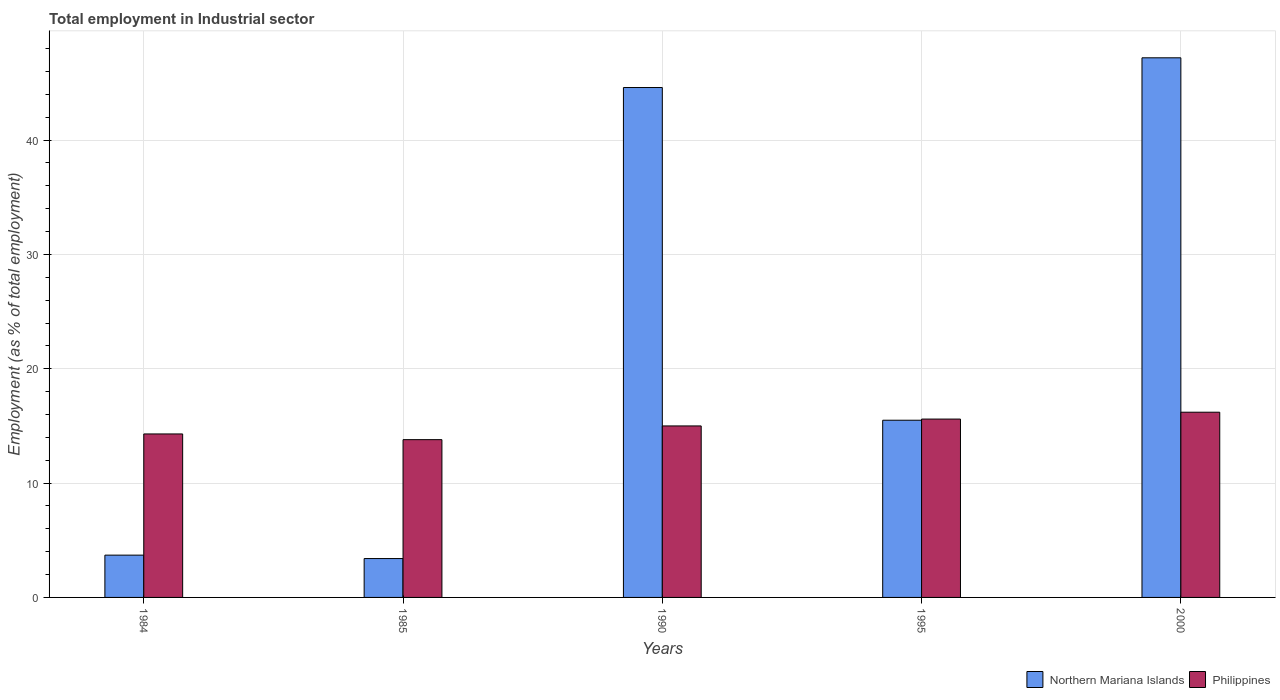How many different coloured bars are there?
Your answer should be very brief. 2. Are the number of bars per tick equal to the number of legend labels?
Your answer should be compact. Yes. What is the label of the 2nd group of bars from the left?
Your answer should be compact. 1985. In how many cases, is the number of bars for a given year not equal to the number of legend labels?
Offer a very short reply. 0. What is the employment in industrial sector in Philippines in 2000?
Make the answer very short. 16.2. Across all years, what is the maximum employment in industrial sector in Philippines?
Your answer should be compact. 16.2. Across all years, what is the minimum employment in industrial sector in Philippines?
Offer a terse response. 13.8. In which year was the employment in industrial sector in Philippines maximum?
Keep it short and to the point. 2000. In which year was the employment in industrial sector in Philippines minimum?
Your answer should be very brief. 1985. What is the total employment in industrial sector in Philippines in the graph?
Your answer should be compact. 74.9. What is the difference between the employment in industrial sector in Philippines in 1995 and that in 2000?
Keep it short and to the point. -0.6. What is the difference between the employment in industrial sector in Philippines in 1995 and the employment in industrial sector in Northern Mariana Islands in 1984?
Your answer should be very brief. 11.9. What is the average employment in industrial sector in Northern Mariana Islands per year?
Provide a succinct answer. 22.88. In the year 1985, what is the difference between the employment in industrial sector in Philippines and employment in industrial sector in Northern Mariana Islands?
Provide a succinct answer. 10.4. What is the ratio of the employment in industrial sector in Philippines in 1995 to that in 2000?
Ensure brevity in your answer.  0.96. Is the employment in industrial sector in Northern Mariana Islands in 1984 less than that in 2000?
Your response must be concise. Yes. What is the difference between the highest and the second highest employment in industrial sector in Philippines?
Ensure brevity in your answer.  0.6. What is the difference between the highest and the lowest employment in industrial sector in Northern Mariana Islands?
Your response must be concise. 43.8. Is the sum of the employment in industrial sector in Philippines in 1990 and 1995 greater than the maximum employment in industrial sector in Northern Mariana Islands across all years?
Your answer should be very brief. No. What does the 2nd bar from the right in 1990 represents?
Provide a short and direct response. Northern Mariana Islands. How many bars are there?
Your response must be concise. 10. Are all the bars in the graph horizontal?
Your answer should be compact. No. What is the difference between two consecutive major ticks on the Y-axis?
Ensure brevity in your answer.  10. Are the values on the major ticks of Y-axis written in scientific E-notation?
Give a very brief answer. No. Does the graph contain any zero values?
Ensure brevity in your answer.  No. Where does the legend appear in the graph?
Make the answer very short. Bottom right. How many legend labels are there?
Keep it short and to the point. 2. How are the legend labels stacked?
Your answer should be compact. Horizontal. What is the title of the graph?
Keep it short and to the point. Total employment in Industrial sector. Does "Malawi" appear as one of the legend labels in the graph?
Offer a terse response. No. What is the label or title of the Y-axis?
Your answer should be very brief. Employment (as % of total employment). What is the Employment (as % of total employment) of Northern Mariana Islands in 1984?
Your response must be concise. 3.7. What is the Employment (as % of total employment) in Philippines in 1984?
Your answer should be very brief. 14.3. What is the Employment (as % of total employment) of Northern Mariana Islands in 1985?
Give a very brief answer. 3.4. What is the Employment (as % of total employment) of Philippines in 1985?
Provide a short and direct response. 13.8. What is the Employment (as % of total employment) in Northern Mariana Islands in 1990?
Keep it short and to the point. 44.6. What is the Employment (as % of total employment) in Philippines in 1995?
Your response must be concise. 15.6. What is the Employment (as % of total employment) of Northern Mariana Islands in 2000?
Give a very brief answer. 47.2. What is the Employment (as % of total employment) in Philippines in 2000?
Your answer should be very brief. 16.2. Across all years, what is the maximum Employment (as % of total employment) in Northern Mariana Islands?
Your answer should be very brief. 47.2. Across all years, what is the maximum Employment (as % of total employment) of Philippines?
Provide a succinct answer. 16.2. Across all years, what is the minimum Employment (as % of total employment) in Northern Mariana Islands?
Make the answer very short. 3.4. Across all years, what is the minimum Employment (as % of total employment) of Philippines?
Your answer should be very brief. 13.8. What is the total Employment (as % of total employment) in Northern Mariana Islands in the graph?
Make the answer very short. 114.4. What is the total Employment (as % of total employment) in Philippines in the graph?
Keep it short and to the point. 74.9. What is the difference between the Employment (as % of total employment) of Northern Mariana Islands in 1984 and that in 1985?
Offer a very short reply. 0.3. What is the difference between the Employment (as % of total employment) of Philippines in 1984 and that in 1985?
Keep it short and to the point. 0.5. What is the difference between the Employment (as % of total employment) of Northern Mariana Islands in 1984 and that in 1990?
Make the answer very short. -40.9. What is the difference between the Employment (as % of total employment) in Northern Mariana Islands in 1984 and that in 1995?
Ensure brevity in your answer.  -11.8. What is the difference between the Employment (as % of total employment) in Northern Mariana Islands in 1984 and that in 2000?
Ensure brevity in your answer.  -43.5. What is the difference between the Employment (as % of total employment) in Northern Mariana Islands in 1985 and that in 1990?
Ensure brevity in your answer.  -41.2. What is the difference between the Employment (as % of total employment) in Northern Mariana Islands in 1985 and that in 1995?
Your answer should be very brief. -12.1. What is the difference between the Employment (as % of total employment) of Northern Mariana Islands in 1985 and that in 2000?
Provide a short and direct response. -43.8. What is the difference between the Employment (as % of total employment) in Northern Mariana Islands in 1990 and that in 1995?
Ensure brevity in your answer.  29.1. What is the difference between the Employment (as % of total employment) in Philippines in 1990 and that in 1995?
Keep it short and to the point. -0.6. What is the difference between the Employment (as % of total employment) of Philippines in 1990 and that in 2000?
Your answer should be compact. -1.2. What is the difference between the Employment (as % of total employment) of Northern Mariana Islands in 1995 and that in 2000?
Provide a succinct answer. -31.7. What is the difference between the Employment (as % of total employment) of Philippines in 1995 and that in 2000?
Offer a very short reply. -0.6. What is the difference between the Employment (as % of total employment) of Northern Mariana Islands in 1984 and the Employment (as % of total employment) of Philippines in 1990?
Your answer should be compact. -11.3. What is the difference between the Employment (as % of total employment) of Northern Mariana Islands in 1984 and the Employment (as % of total employment) of Philippines in 2000?
Your response must be concise. -12.5. What is the difference between the Employment (as % of total employment) of Northern Mariana Islands in 1985 and the Employment (as % of total employment) of Philippines in 1990?
Make the answer very short. -11.6. What is the difference between the Employment (as % of total employment) in Northern Mariana Islands in 1985 and the Employment (as % of total employment) in Philippines in 1995?
Your response must be concise. -12.2. What is the difference between the Employment (as % of total employment) of Northern Mariana Islands in 1985 and the Employment (as % of total employment) of Philippines in 2000?
Provide a succinct answer. -12.8. What is the difference between the Employment (as % of total employment) in Northern Mariana Islands in 1990 and the Employment (as % of total employment) in Philippines in 2000?
Provide a succinct answer. 28.4. What is the difference between the Employment (as % of total employment) in Northern Mariana Islands in 1995 and the Employment (as % of total employment) in Philippines in 2000?
Offer a very short reply. -0.7. What is the average Employment (as % of total employment) of Northern Mariana Islands per year?
Ensure brevity in your answer.  22.88. What is the average Employment (as % of total employment) of Philippines per year?
Your answer should be compact. 14.98. In the year 1985, what is the difference between the Employment (as % of total employment) of Northern Mariana Islands and Employment (as % of total employment) of Philippines?
Give a very brief answer. -10.4. In the year 1990, what is the difference between the Employment (as % of total employment) of Northern Mariana Islands and Employment (as % of total employment) of Philippines?
Provide a succinct answer. 29.6. In the year 2000, what is the difference between the Employment (as % of total employment) of Northern Mariana Islands and Employment (as % of total employment) of Philippines?
Provide a short and direct response. 31. What is the ratio of the Employment (as % of total employment) of Northern Mariana Islands in 1984 to that in 1985?
Provide a succinct answer. 1.09. What is the ratio of the Employment (as % of total employment) of Philippines in 1984 to that in 1985?
Your answer should be compact. 1.04. What is the ratio of the Employment (as % of total employment) of Northern Mariana Islands in 1984 to that in 1990?
Ensure brevity in your answer.  0.08. What is the ratio of the Employment (as % of total employment) of Philippines in 1984 to that in 1990?
Offer a very short reply. 0.95. What is the ratio of the Employment (as % of total employment) of Northern Mariana Islands in 1984 to that in 1995?
Your response must be concise. 0.24. What is the ratio of the Employment (as % of total employment) in Northern Mariana Islands in 1984 to that in 2000?
Ensure brevity in your answer.  0.08. What is the ratio of the Employment (as % of total employment) in Philippines in 1984 to that in 2000?
Offer a very short reply. 0.88. What is the ratio of the Employment (as % of total employment) of Northern Mariana Islands in 1985 to that in 1990?
Your answer should be compact. 0.08. What is the ratio of the Employment (as % of total employment) of Northern Mariana Islands in 1985 to that in 1995?
Make the answer very short. 0.22. What is the ratio of the Employment (as % of total employment) of Philippines in 1985 to that in 1995?
Your response must be concise. 0.88. What is the ratio of the Employment (as % of total employment) of Northern Mariana Islands in 1985 to that in 2000?
Keep it short and to the point. 0.07. What is the ratio of the Employment (as % of total employment) of Philippines in 1985 to that in 2000?
Keep it short and to the point. 0.85. What is the ratio of the Employment (as % of total employment) of Northern Mariana Islands in 1990 to that in 1995?
Provide a succinct answer. 2.88. What is the ratio of the Employment (as % of total employment) in Philippines in 1990 to that in 1995?
Give a very brief answer. 0.96. What is the ratio of the Employment (as % of total employment) of Northern Mariana Islands in 1990 to that in 2000?
Provide a short and direct response. 0.94. What is the ratio of the Employment (as % of total employment) of Philippines in 1990 to that in 2000?
Your answer should be very brief. 0.93. What is the ratio of the Employment (as % of total employment) of Northern Mariana Islands in 1995 to that in 2000?
Offer a very short reply. 0.33. What is the difference between the highest and the second highest Employment (as % of total employment) in Philippines?
Give a very brief answer. 0.6. What is the difference between the highest and the lowest Employment (as % of total employment) of Northern Mariana Islands?
Make the answer very short. 43.8. 